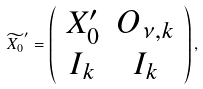Convert formula to latex. <formula><loc_0><loc_0><loc_500><loc_500>\widetilde { X _ { 0 } } ^ { \prime } = \left ( \begin{array} { c c } X _ { 0 } ^ { \prime } & O _ { \nu , k } \\ I _ { k } & I _ { k } \end{array} \right ) ,</formula> 